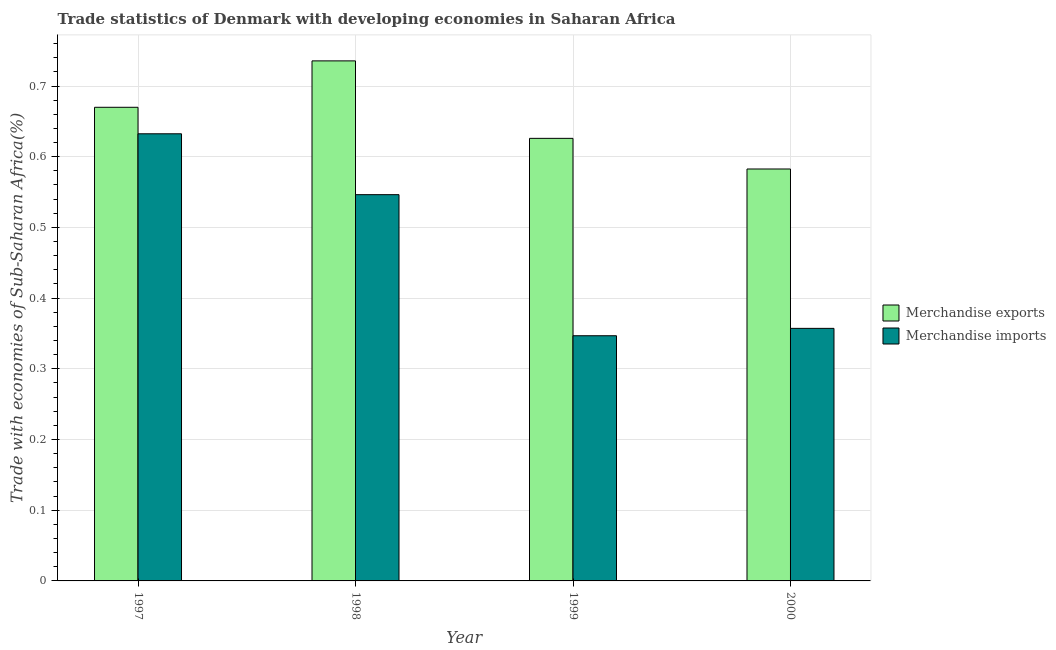How many different coloured bars are there?
Offer a very short reply. 2. Are the number of bars on each tick of the X-axis equal?
Provide a short and direct response. Yes. How many bars are there on the 4th tick from the left?
Your answer should be compact. 2. What is the label of the 3rd group of bars from the left?
Give a very brief answer. 1999. What is the merchandise exports in 1997?
Make the answer very short. 0.67. Across all years, what is the maximum merchandise imports?
Offer a very short reply. 0.63. Across all years, what is the minimum merchandise imports?
Provide a short and direct response. 0.35. In which year was the merchandise imports maximum?
Your response must be concise. 1997. In which year was the merchandise exports minimum?
Keep it short and to the point. 2000. What is the total merchandise exports in the graph?
Offer a terse response. 2.61. What is the difference between the merchandise imports in 1997 and that in 1999?
Ensure brevity in your answer.  0.29. What is the difference between the merchandise imports in 1997 and the merchandise exports in 1998?
Provide a succinct answer. 0.09. What is the average merchandise exports per year?
Make the answer very short. 0.65. In the year 1998, what is the difference between the merchandise exports and merchandise imports?
Offer a terse response. 0. In how many years, is the merchandise imports greater than 0.44 %?
Your response must be concise. 2. What is the ratio of the merchandise imports in 1998 to that in 2000?
Provide a succinct answer. 1.53. Is the merchandise exports in 1998 less than that in 1999?
Your answer should be very brief. No. Is the difference between the merchandise exports in 1997 and 1999 greater than the difference between the merchandise imports in 1997 and 1999?
Provide a succinct answer. No. What is the difference between the highest and the second highest merchandise exports?
Provide a succinct answer. 0.07. What is the difference between the highest and the lowest merchandise imports?
Offer a very short reply. 0.29. Is the sum of the merchandise imports in 1997 and 2000 greater than the maximum merchandise exports across all years?
Make the answer very short. Yes. What does the 2nd bar from the right in 1999 represents?
Provide a short and direct response. Merchandise exports. Are all the bars in the graph horizontal?
Your answer should be compact. No. How many years are there in the graph?
Offer a terse response. 4. Does the graph contain any zero values?
Provide a succinct answer. No. Where does the legend appear in the graph?
Give a very brief answer. Center right. How are the legend labels stacked?
Your answer should be very brief. Vertical. What is the title of the graph?
Keep it short and to the point. Trade statistics of Denmark with developing economies in Saharan Africa. What is the label or title of the X-axis?
Ensure brevity in your answer.  Year. What is the label or title of the Y-axis?
Ensure brevity in your answer.  Trade with economies of Sub-Saharan Africa(%). What is the Trade with economies of Sub-Saharan Africa(%) of Merchandise exports in 1997?
Your answer should be very brief. 0.67. What is the Trade with economies of Sub-Saharan Africa(%) in Merchandise imports in 1997?
Keep it short and to the point. 0.63. What is the Trade with economies of Sub-Saharan Africa(%) of Merchandise exports in 1998?
Give a very brief answer. 0.74. What is the Trade with economies of Sub-Saharan Africa(%) in Merchandise imports in 1998?
Provide a succinct answer. 0.55. What is the Trade with economies of Sub-Saharan Africa(%) of Merchandise exports in 1999?
Keep it short and to the point. 0.63. What is the Trade with economies of Sub-Saharan Africa(%) in Merchandise imports in 1999?
Your answer should be compact. 0.35. What is the Trade with economies of Sub-Saharan Africa(%) of Merchandise exports in 2000?
Provide a short and direct response. 0.58. What is the Trade with economies of Sub-Saharan Africa(%) of Merchandise imports in 2000?
Keep it short and to the point. 0.36. Across all years, what is the maximum Trade with economies of Sub-Saharan Africa(%) of Merchandise exports?
Ensure brevity in your answer.  0.74. Across all years, what is the maximum Trade with economies of Sub-Saharan Africa(%) of Merchandise imports?
Offer a very short reply. 0.63. Across all years, what is the minimum Trade with economies of Sub-Saharan Africa(%) in Merchandise exports?
Keep it short and to the point. 0.58. Across all years, what is the minimum Trade with economies of Sub-Saharan Africa(%) in Merchandise imports?
Your response must be concise. 0.35. What is the total Trade with economies of Sub-Saharan Africa(%) in Merchandise exports in the graph?
Provide a short and direct response. 2.61. What is the total Trade with economies of Sub-Saharan Africa(%) of Merchandise imports in the graph?
Provide a succinct answer. 1.88. What is the difference between the Trade with economies of Sub-Saharan Africa(%) of Merchandise exports in 1997 and that in 1998?
Offer a terse response. -0.07. What is the difference between the Trade with economies of Sub-Saharan Africa(%) in Merchandise imports in 1997 and that in 1998?
Give a very brief answer. 0.09. What is the difference between the Trade with economies of Sub-Saharan Africa(%) in Merchandise exports in 1997 and that in 1999?
Provide a short and direct response. 0.04. What is the difference between the Trade with economies of Sub-Saharan Africa(%) in Merchandise imports in 1997 and that in 1999?
Your answer should be compact. 0.29. What is the difference between the Trade with economies of Sub-Saharan Africa(%) of Merchandise exports in 1997 and that in 2000?
Ensure brevity in your answer.  0.09. What is the difference between the Trade with economies of Sub-Saharan Africa(%) of Merchandise imports in 1997 and that in 2000?
Your answer should be compact. 0.28. What is the difference between the Trade with economies of Sub-Saharan Africa(%) in Merchandise exports in 1998 and that in 1999?
Your response must be concise. 0.11. What is the difference between the Trade with economies of Sub-Saharan Africa(%) of Merchandise imports in 1998 and that in 1999?
Make the answer very short. 0.2. What is the difference between the Trade with economies of Sub-Saharan Africa(%) in Merchandise exports in 1998 and that in 2000?
Offer a terse response. 0.15. What is the difference between the Trade with economies of Sub-Saharan Africa(%) of Merchandise imports in 1998 and that in 2000?
Make the answer very short. 0.19. What is the difference between the Trade with economies of Sub-Saharan Africa(%) of Merchandise exports in 1999 and that in 2000?
Offer a very short reply. 0.04. What is the difference between the Trade with economies of Sub-Saharan Africa(%) in Merchandise imports in 1999 and that in 2000?
Offer a very short reply. -0.01. What is the difference between the Trade with economies of Sub-Saharan Africa(%) of Merchandise exports in 1997 and the Trade with economies of Sub-Saharan Africa(%) of Merchandise imports in 1998?
Give a very brief answer. 0.12. What is the difference between the Trade with economies of Sub-Saharan Africa(%) of Merchandise exports in 1997 and the Trade with economies of Sub-Saharan Africa(%) of Merchandise imports in 1999?
Your response must be concise. 0.32. What is the difference between the Trade with economies of Sub-Saharan Africa(%) of Merchandise exports in 1997 and the Trade with economies of Sub-Saharan Africa(%) of Merchandise imports in 2000?
Keep it short and to the point. 0.31. What is the difference between the Trade with economies of Sub-Saharan Africa(%) of Merchandise exports in 1998 and the Trade with economies of Sub-Saharan Africa(%) of Merchandise imports in 1999?
Offer a very short reply. 0.39. What is the difference between the Trade with economies of Sub-Saharan Africa(%) in Merchandise exports in 1998 and the Trade with economies of Sub-Saharan Africa(%) in Merchandise imports in 2000?
Provide a short and direct response. 0.38. What is the difference between the Trade with economies of Sub-Saharan Africa(%) in Merchandise exports in 1999 and the Trade with economies of Sub-Saharan Africa(%) in Merchandise imports in 2000?
Offer a very short reply. 0.27. What is the average Trade with economies of Sub-Saharan Africa(%) of Merchandise exports per year?
Your response must be concise. 0.65. What is the average Trade with economies of Sub-Saharan Africa(%) of Merchandise imports per year?
Provide a succinct answer. 0.47. In the year 1997, what is the difference between the Trade with economies of Sub-Saharan Africa(%) in Merchandise exports and Trade with economies of Sub-Saharan Africa(%) in Merchandise imports?
Your answer should be very brief. 0.04. In the year 1998, what is the difference between the Trade with economies of Sub-Saharan Africa(%) of Merchandise exports and Trade with economies of Sub-Saharan Africa(%) of Merchandise imports?
Keep it short and to the point. 0.19. In the year 1999, what is the difference between the Trade with economies of Sub-Saharan Africa(%) in Merchandise exports and Trade with economies of Sub-Saharan Africa(%) in Merchandise imports?
Give a very brief answer. 0.28. In the year 2000, what is the difference between the Trade with economies of Sub-Saharan Africa(%) in Merchandise exports and Trade with economies of Sub-Saharan Africa(%) in Merchandise imports?
Your answer should be very brief. 0.23. What is the ratio of the Trade with economies of Sub-Saharan Africa(%) of Merchandise exports in 1997 to that in 1998?
Your answer should be compact. 0.91. What is the ratio of the Trade with economies of Sub-Saharan Africa(%) of Merchandise imports in 1997 to that in 1998?
Keep it short and to the point. 1.16. What is the ratio of the Trade with economies of Sub-Saharan Africa(%) in Merchandise exports in 1997 to that in 1999?
Your response must be concise. 1.07. What is the ratio of the Trade with economies of Sub-Saharan Africa(%) of Merchandise imports in 1997 to that in 1999?
Keep it short and to the point. 1.82. What is the ratio of the Trade with economies of Sub-Saharan Africa(%) in Merchandise exports in 1997 to that in 2000?
Keep it short and to the point. 1.15. What is the ratio of the Trade with economies of Sub-Saharan Africa(%) of Merchandise imports in 1997 to that in 2000?
Keep it short and to the point. 1.77. What is the ratio of the Trade with economies of Sub-Saharan Africa(%) in Merchandise exports in 1998 to that in 1999?
Make the answer very short. 1.18. What is the ratio of the Trade with economies of Sub-Saharan Africa(%) of Merchandise imports in 1998 to that in 1999?
Keep it short and to the point. 1.58. What is the ratio of the Trade with economies of Sub-Saharan Africa(%) of Merchandise exports in 1998 to that in 2000?
Your answer should be compact. 1.26. What is the ratio of the Trade with economies of Sub-Saharan Africa(%) of Merchandise imports in 1998 to that in 2000?
Ensure brevity in your answer.  1.53. What is the ratio of the Trade with economies of Sub-Saharan Africa(%) in Merchandise exports in 1999 to that in 2000?
Your response must be concise. 1.07. What is the ratio of the Trade with economies of Sub-Saharan Africa(%) of Merchandise imports in 1999 to that in 2000?
Provide a succinct answer. 0.97. What is the difference between the highest and the second highest Trade with economies of Sub-Saharan Africa(%) in Merchandise exports?
Provide a succinct answer. 0.07. What is the difference between the highest and the second highest Trade with economies of Sub-Saharan Africa(%) of Merchandise imports?
Your response must be concise. 0.09. What is the difference between the highest and the lowest Trade with economies of Sub-Saharan Africa(%) of Merchandise exports?
Offer a terse response. 0.15. What is the difference between the highest and the lowest Trade with economies of Sub-Saharan Africa(%) of Merchandise imports?
Provide a succinct answer. 0.29. 